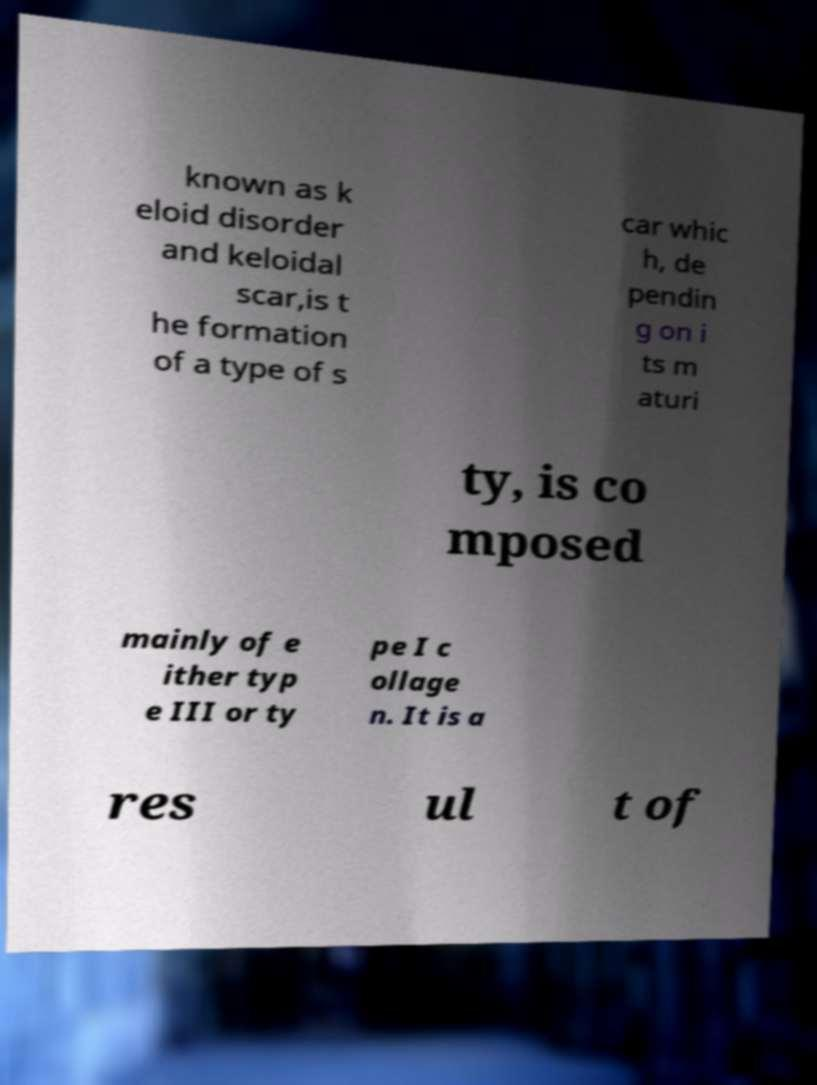Could you extract and type out the text from this image? known as k eloid disorder and keloidal scar,is t he formation of a type of s car whic h, de pendin g on i ts m aturi ty, is co mposed mainly of e ither typ e III or ty pe I c ollage n. It is a res ul t of 